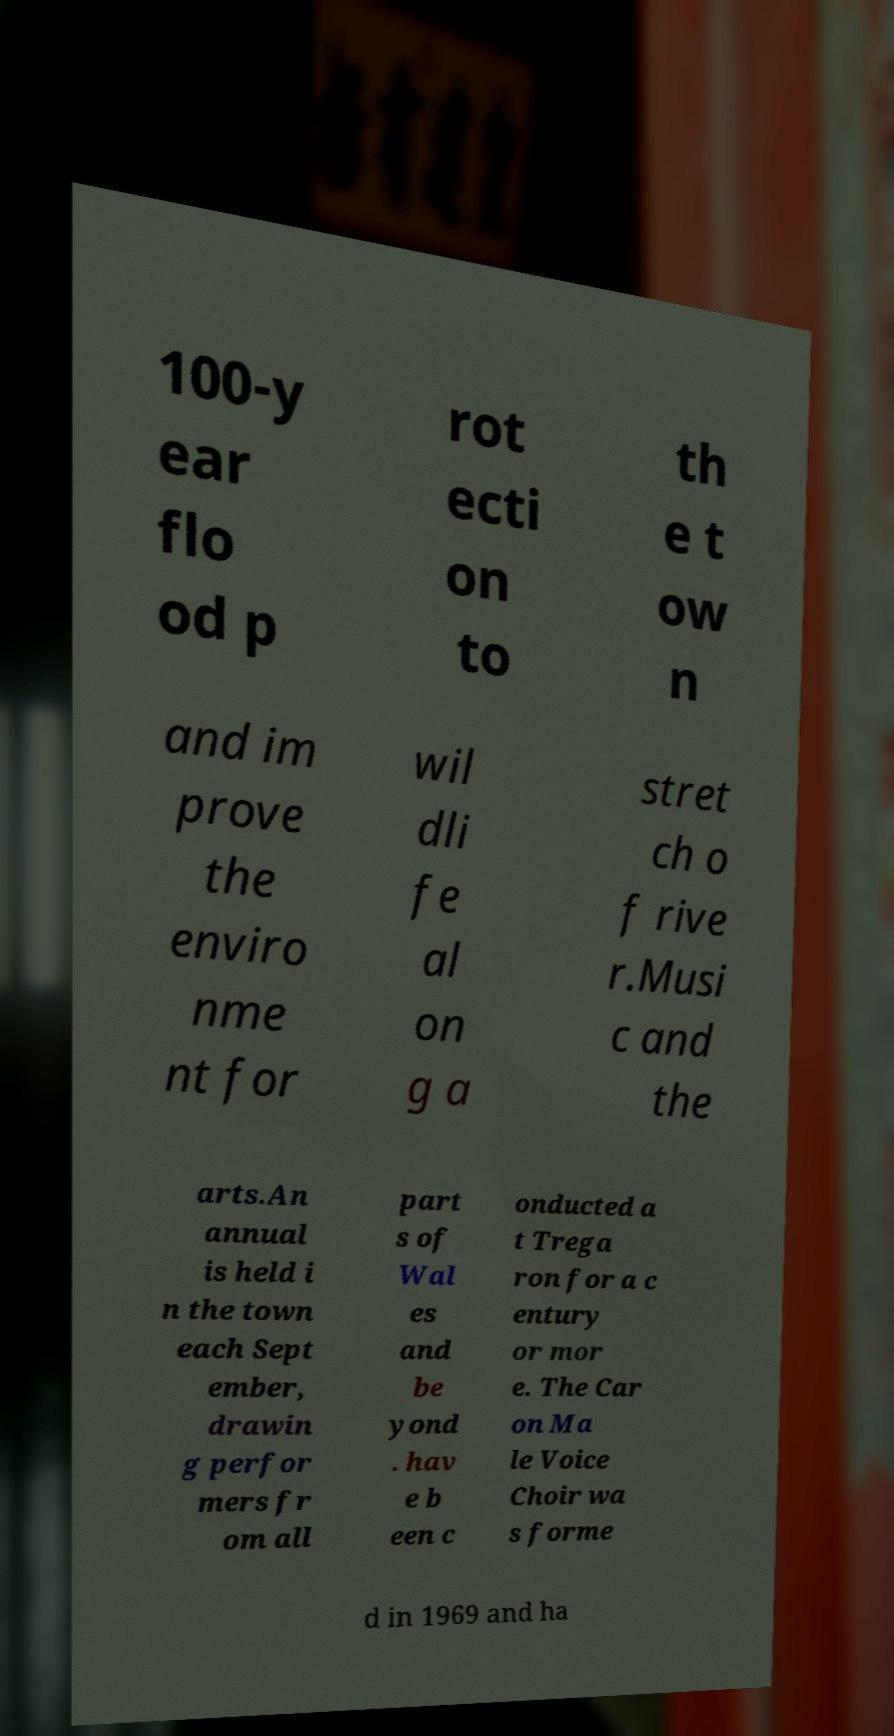What messages or text are displayed in this image? I need them in a readable, typed format. 100-y ear flo od p rot ecti on to th e t ow n and im prove the enviro nme nt for wil dli fe al on g a stret ch o f rive r.Musi c and the arts.An annual is held i n the town each Sept ember, drawin g perfor mers fr om all part s of Wal es and be yond . hav e b een c onducted a t Trega ron for a c entury or mor e. The Car on Ma le Voice Choir wa s forme d in 1969 and ha 